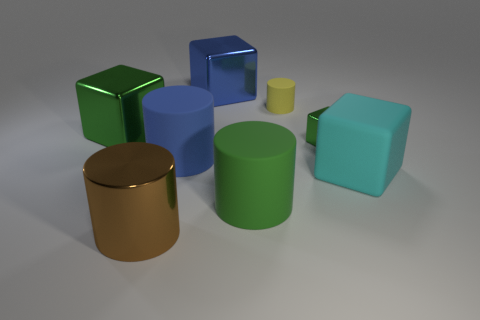Subtract all small green blocks. How many blocks are left? 3 Subtract all green cylinders. How many green blocks are left? 2 Add 2 tiny green cubes. How many objects exist? 10 Subtract 1 cylinders. How many cylinders are left? 3 Subtract all yellow cylinders. How many cylinders are left? 3 Subtract all green cubes. Subtract all cyan spheres. How many cubes are left? 2 Subtract all matte things. Subtract all big blue shiny objects. How many objects are left? 3 Add 5 yellow cylinders. How many yellow cylinders are left? 6 Add 3 tiny rubber objects. How many tiny rubber objects exist? 4 Subtract 0 purple cylinders. How many objects are left? 8 